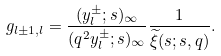Convert formula to latex. <formula><loc_0><loc_0><loc_500><loc_500>g _ { l \pm 1 , l } = \frac { ( y _ { l } ^ { \pm } ; s ) _ { \infty } } { ( q ^ { 2 } y _ { l } ^ { \pm } ; s ) _ { \infty } } \frac { 1 } { \widetilde { \xi } ( s ; s , q ) } .</formula> 